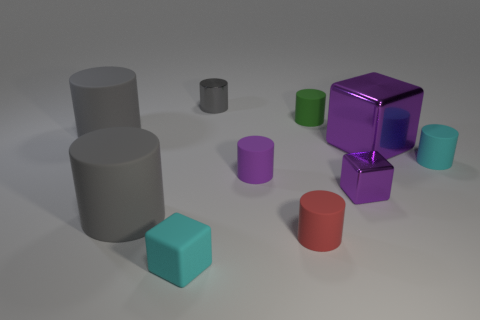What feeling does the arrangement of objects convey? The arrangement of objects conveys a sense of order and simplicity. The variety of sizes, the neat spacing, and the soft lighting give off a calm and deliberate aesthetic, possibly intended to focus attention on form and color contrast. 